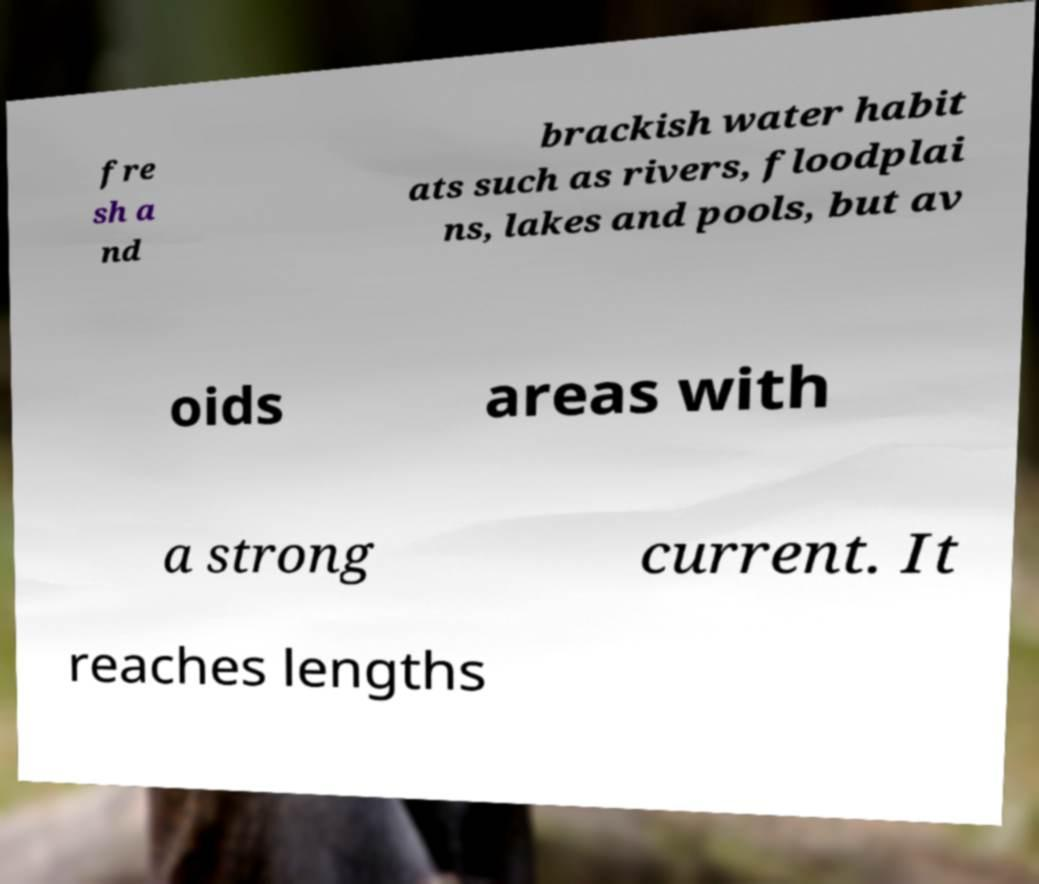For documentation purposes, I need the text within this image transcribed. Could you provide that? fre sh a nd brackish water habit ats such as rivers, floodplai ns, lakes and pools, but av oids areas with a strong current. It reaches lengths 